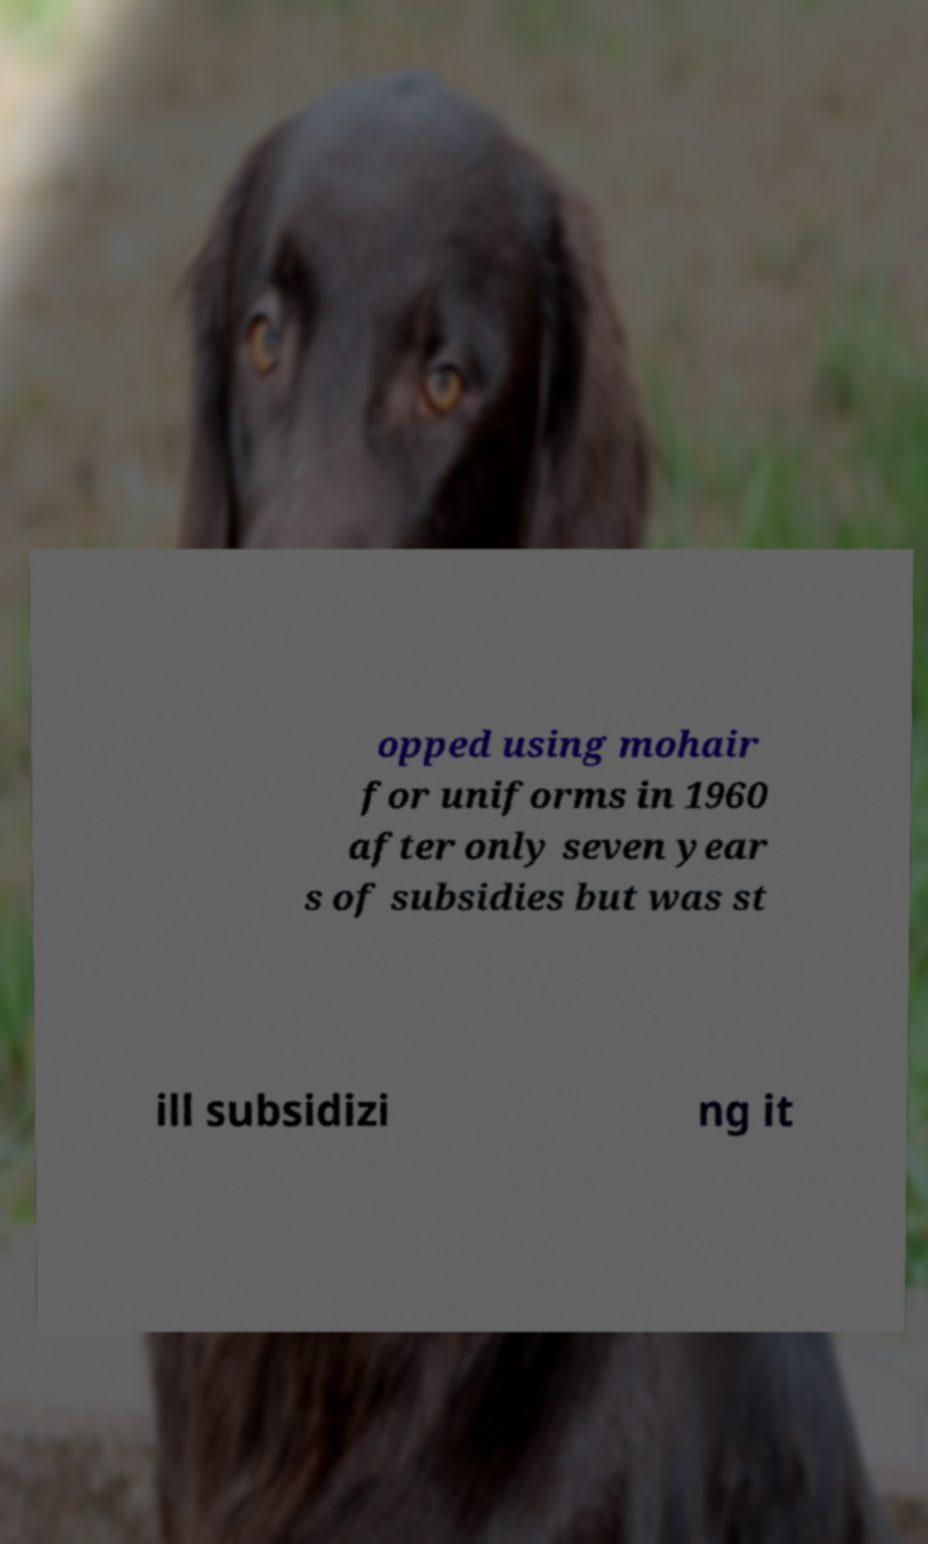For documentation purposes, I need the text within this image transcribed. Could you provide that? opped using mohair for uniforms in 1960 after only seven year s of subsidies but was st ill subsidizi ng it 